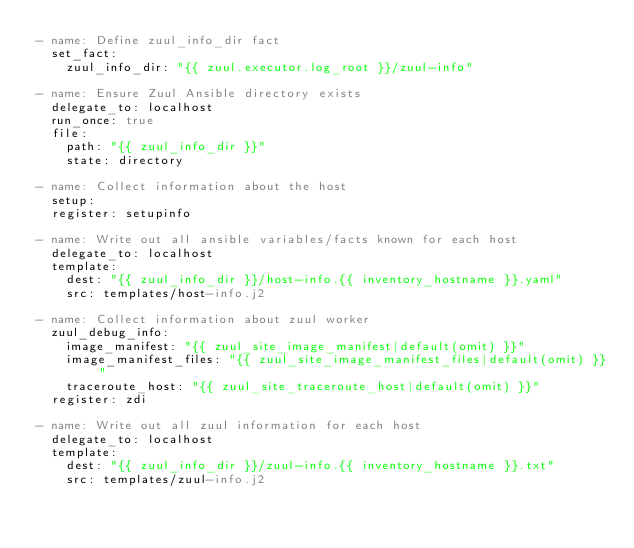Convert code to text. <code><loc_0><loc_0><loc_500><loc_500><_YAML_>- name: Define zuul_info_dir fact
  set_fact:
    zuul_info_dir: "{{ zuul.executor.log_root }}/zuul-info"

- name: Ensure Zuul Ansible directory exists
  delegate_to: localhost
  run_once: true
  file:
    path: "{{ zuul_info_dir }}"
    state: directory

- name: Collect information about the host
  setup:
  register: setupinfo

- name: Write out all ansible variables/facts known for each host
  delegate_to: localhost
  template:
    dest: "{{ zuul_info_dir }}/host-info.{{ inventory_hostname }}.yaml"
    src: templates/host-info.j2

- name: Collect information about zuul worker
  zuul_debug_info:
    image_manifest: "{{ zuul_site_image_manifest|default(omit) }}"
    image_manifest_files: "{{ zuul_site_image_manifest_files|default(omit) }}"
    traceroute_host: "{{ zuul_site_traceroute_host|default(omit) }}"
  register: zdi

- name: Write out all zuul information for each host
  delegate_to: localhost
  template:
    dest: "{{ zuul_info_dir }}/zuul-info.{{ inventory_hostname }}.txt"
    src: templates/zuul-info.j2
</code> 